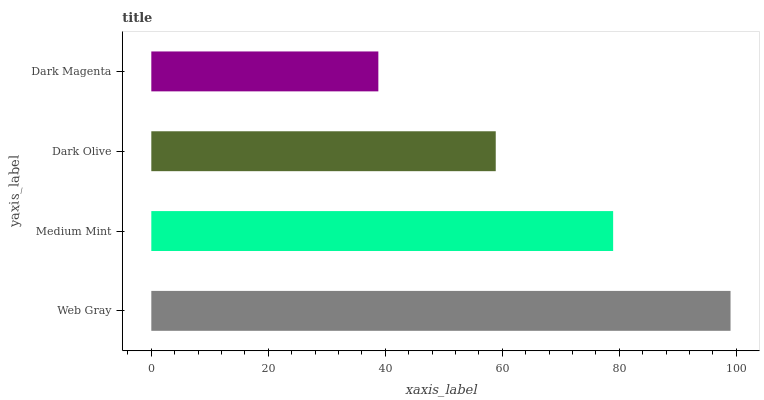Is Dark Magenta the minimum?
Answer yes or no. Yes. Is Web Gray the maximum?
Answer yes or no. Yes. Is Medium Mint the minimum?
Answer yes or no. No. Is Medium Mint the maximum?
Answer yes or no. No. Is Web Gray greater than Medium Mint?
Answer yes or no. Yes. Is Medium Mint less than Web Gray?
Answer yes or no. Yes. Is Medium Mint greater than Web Gray?
Answer yes or no. No. Is Web Gray less than Medium Mint?
Answer yes or no. No. Is Medium Mint the high median?
Answer yes or no. Yes. Is Dark Olive the low median?
Answer yes or no. Yes. Is Dark Magenta the high median?
Answer yes or no. No. Is Web Gray the low median?
Answer yes or no. No. 